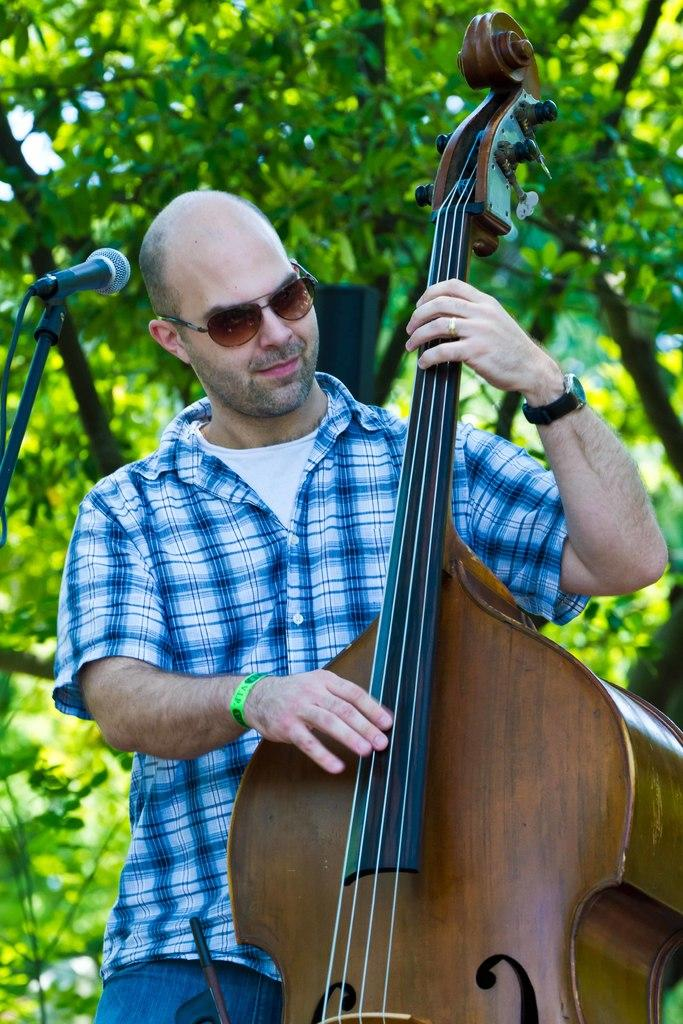What is the main subject of the image? The main subject of the image is a man. What is the man doing in the image? The man is standing in the image. What object is the man holding in his hand? The man is holding a violin in his hand. What can be seen in the background of the image? There are trees visible in the background of the image. How many dimes can be seen on the violin in the image? There are no dimes visible on the violin in the image. Is there a ticket attached to the man's clothing in the image? There is no ticket visible on the man's clothing in the image. 